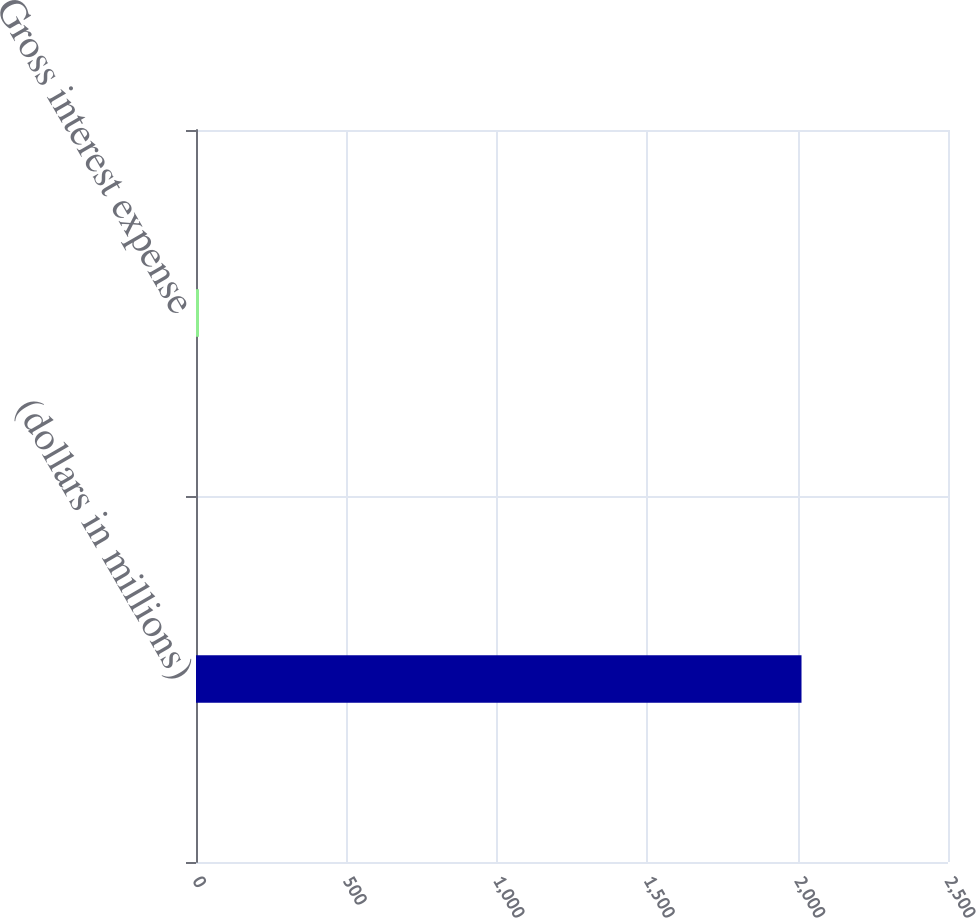Convert chart to OTSL. <chart><loc_0><loc_0><loc_500><loc_500><bar_chart><fcel>(dollars in millions)<fcel>Gross interest expense<nl><fcel>2013<fcel>9.9<nl></chart> 